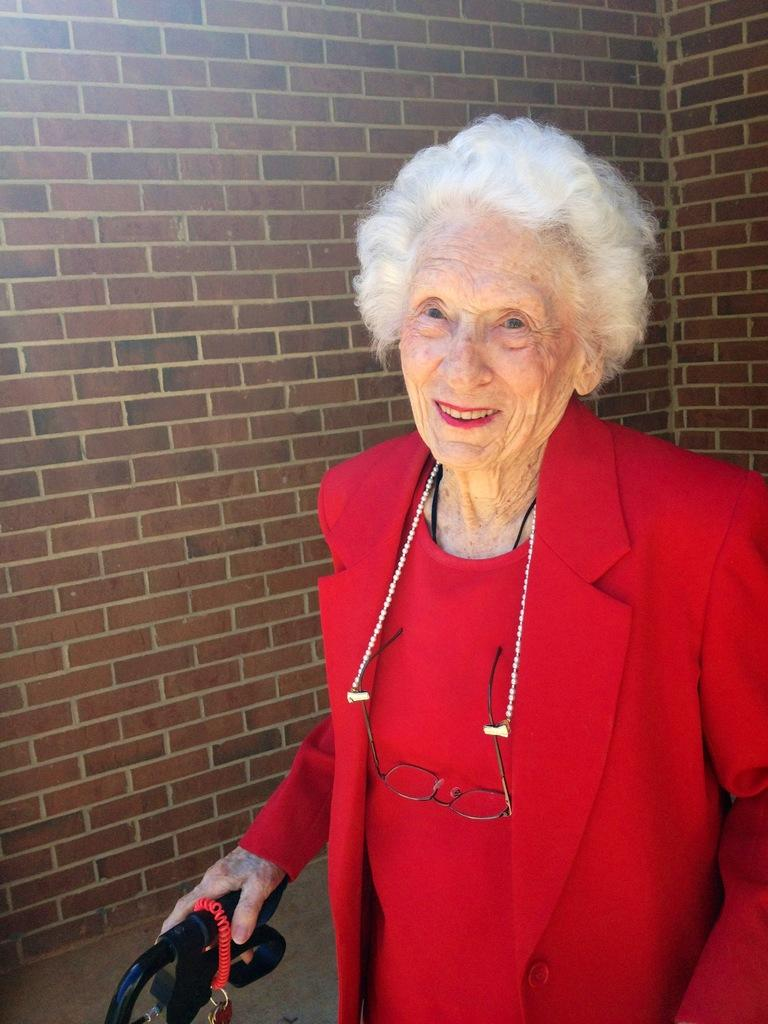Who is present in the image? There is a woman in the image. Where is the woman located in the image? The woman is standing on the right side of the image. What is the woman wearing? The woman is wearing a red dress. What is the woman holding in the image? The woman is holding an object. What can be seen in the background of the image? There is a wall in the background of the image. What type of yoke is the woman using for her hobbies in the image? There is no yoke present in the image, and no information about the woman's hobbies is provided. 